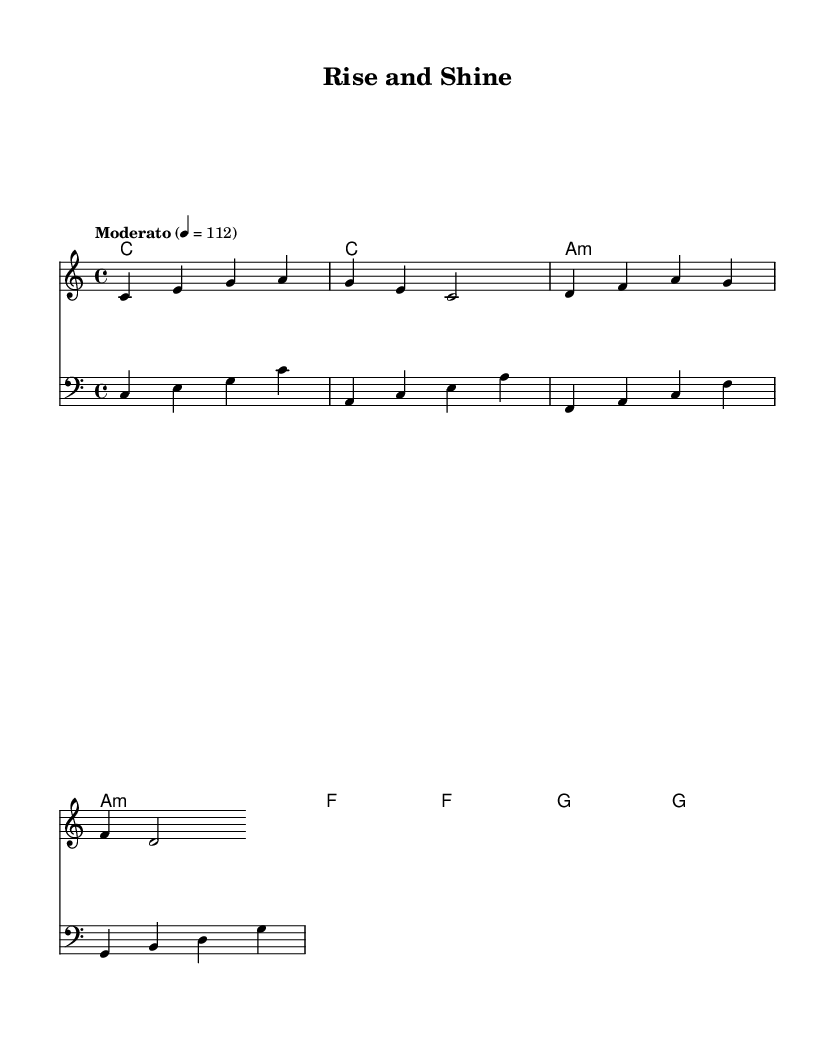What is the key signature of this music? The key signature is C major, which has no sharps or flats.
Answer: C major What is the time signature of this piece? The time signature is indicated at the beginning and is read as four beats per measure, which is shown as a fraction 4/4.
Answer: 4/4 What is the tempo marking of this piece? The tempo marking is displayed as a word above the staff, reading "Moderato," with a metronome marking of 112 beats per minute.
Answer: Moderato How many measures are in the melody? Counting the segments separated by the bar lines in the melody, there are a total of four measures.
Answer: 4 What is the main lyrical theme of the chorus? The chorus emphasizes a positive and motivational message to express oneself and to grow, key phrases include "Rise and shine" and "let your light shine."
Answer: Personal growth How do the harmony chords change in the progression? The chords follow a specific progression through the measures: C, A minor, F, and G, alternating every two measures with some repetition.
Answer: C, A minor, F, G What does the term "clef" indicate in the context of the bass staff? The clef indicates that the notes on the bass staff will be read as lower pitches, specifically the bass clef is used to represent the bass part.
Answer: Bass clef 